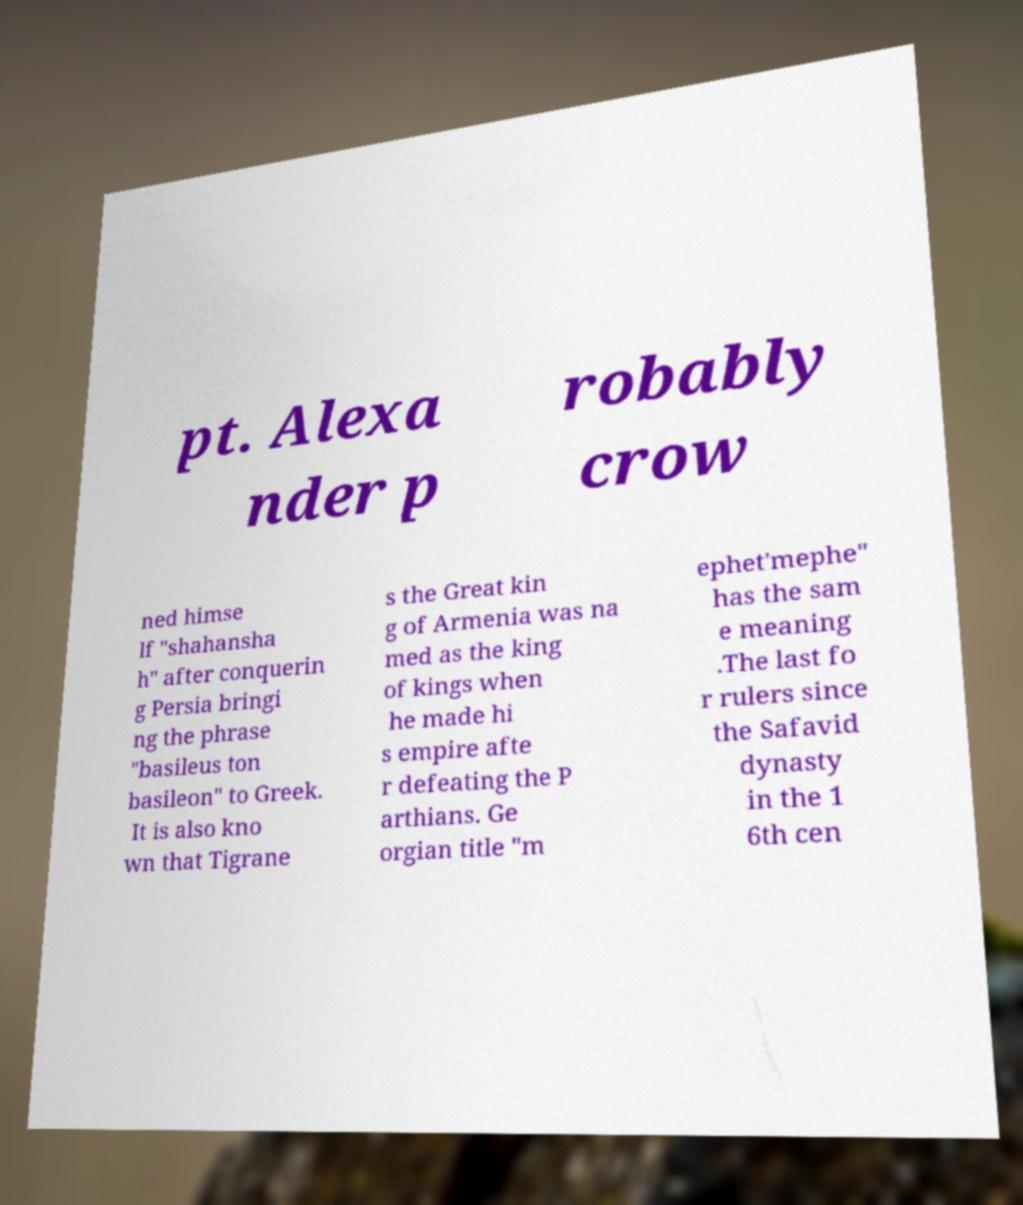Can you read and provide the text displayed in the image?This photo seems to have some interesting text. Can you extract and type it out for me? pt. Alexa nder p robably crow ned himse lf "shahansha h" after conquerin g Persia bringi ng the phrase "basileus ton basileon" to Greek. It is also kno wn that Tigrane s the Great kin g of Armenia was na med as the king of kings when he made hi s empire afte r defeating the P arthians. Ge orgian title "m ephet'mephe" has the sam e meaning .The last fo r rulers since the Safavid dynasty in the 1 6th cen 